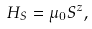Convert formula to latex. <formula><loc_0><loc_0><loc_500><loc_500>H _ { S } = \mu _ { 0 } S ^ { z } ,</formula> 